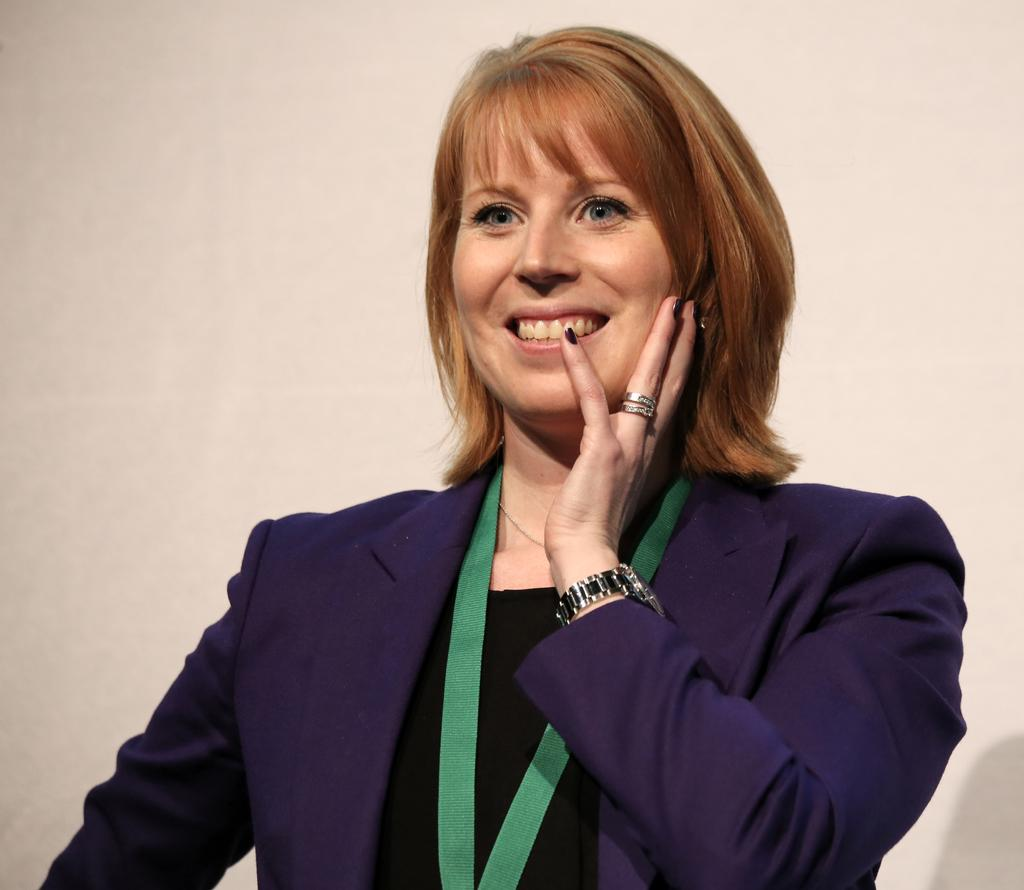What is the person in the image wearing? The person is wearing a blue suit. What accessories does the person have in the image? The person has a green ID card, a wristwatch, and a ring. What is the person's facial expression in the image? The person is smiling in the image. What can be seen in the background of the image? There is a wall in the background of the image. What type of gold object is the person holding in the image? There is no gold object present in the image. Is the person in the image a judge? There is no indication in the image that the person is a judge. 